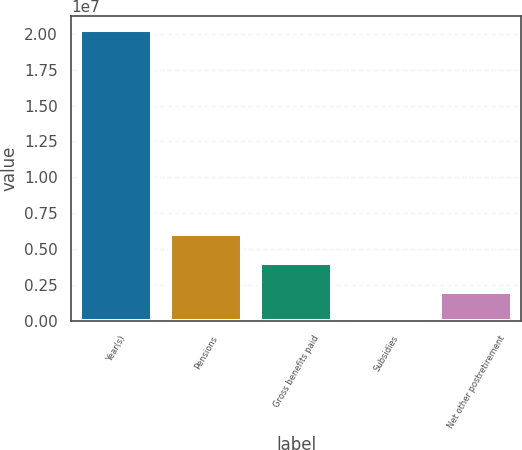Convert chart. <chart><loc_0><loc_0><loc_500><loc_500><bar_chart><fcel>Year(s)<fcel>Pensions<fcel>Gross benefits paid<fcel>Subsidies<fcel>Net other postretirement<nl><fcel>2.0242e+07<fcel>6.07267e+06<fcel>4.04848e+06<fcel>90<fcel>2.02428e+06<nl></chart> 